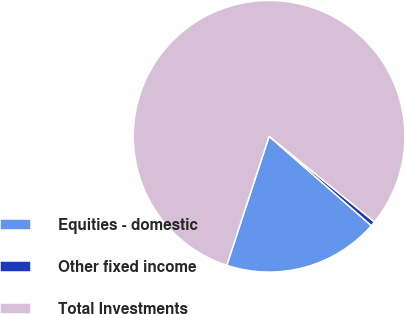Convert chart to OTSL. <chart><loc_0><loc_0><loc_500><loc_500><pie_chart><fcel>Equities - domestic<fcel>Other fixed income<fcel>Total Investments<nl><fcel>18.62%<fcel>0.56%<fcel>80.82%<nl></chart> 